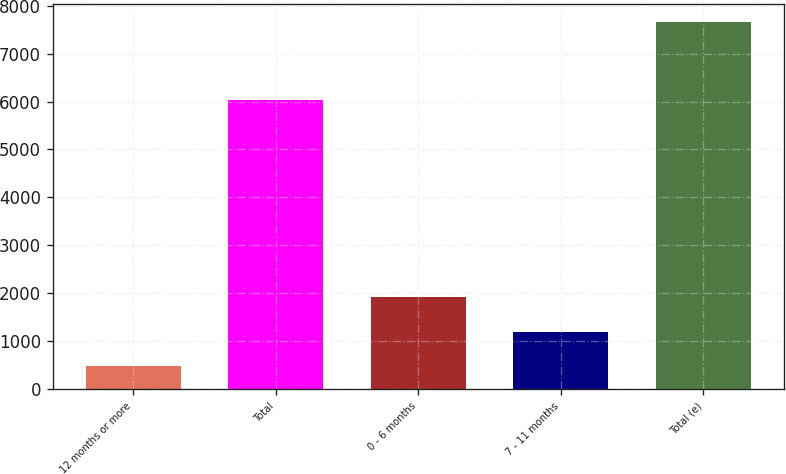Convert chart to OTSL. <chart><loc_0><loc_0><loc_500><loc_500><bar_chart><fcel>12 months or more<fcel>Total<fcel>0 - 6 months<fcel>7 - 11 months<fcel>Total (e)<nl><fcel>478<fcel>6040<fcel>1912.8<fcel>1195.4<fcel>7652<nl></chart> 